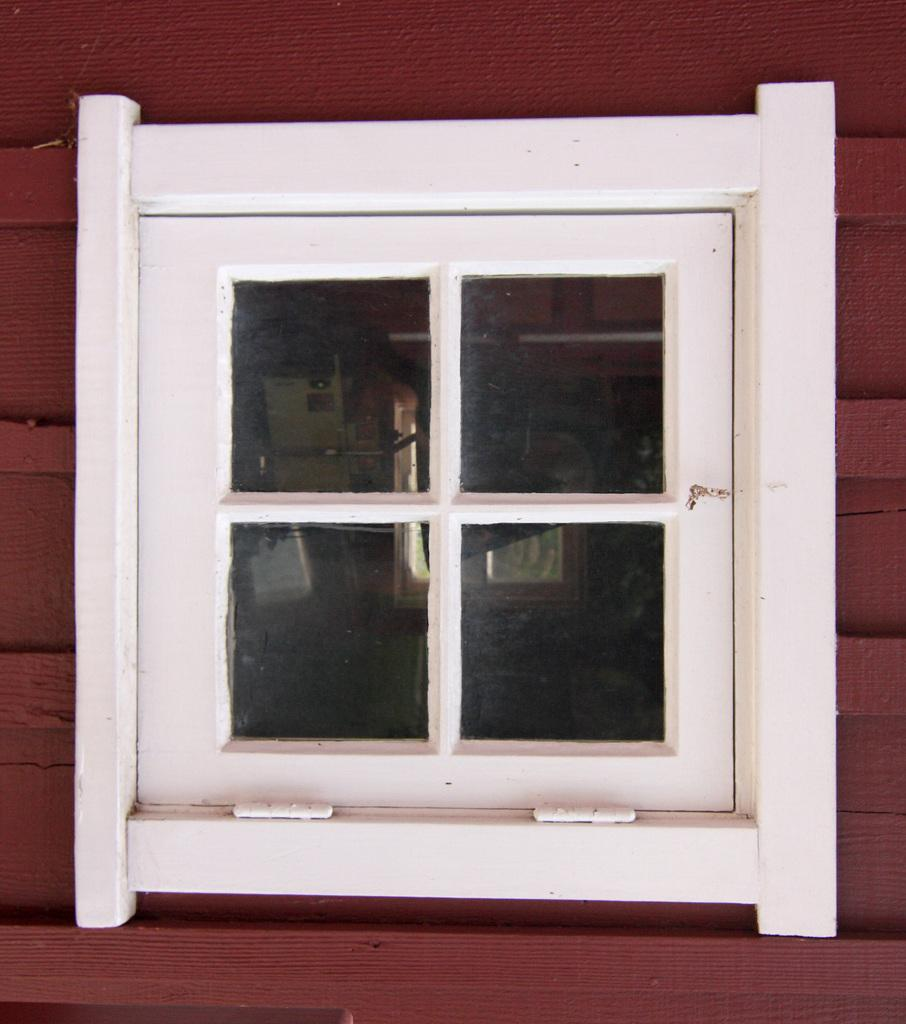What type of opening is present in the image? There is a window in the image. How is the window shaped? The window is in a square shape. How many divisions does the window have? The window has four divisions. What color is the wall that the window is attached to? The wall is in brown color. How is the window connected to the wall? The window is attached to the brown wall. What type of fruit is sitting on the chair in the image? There is no chair or fruit present in the image; it only features a window and a brown wall. 